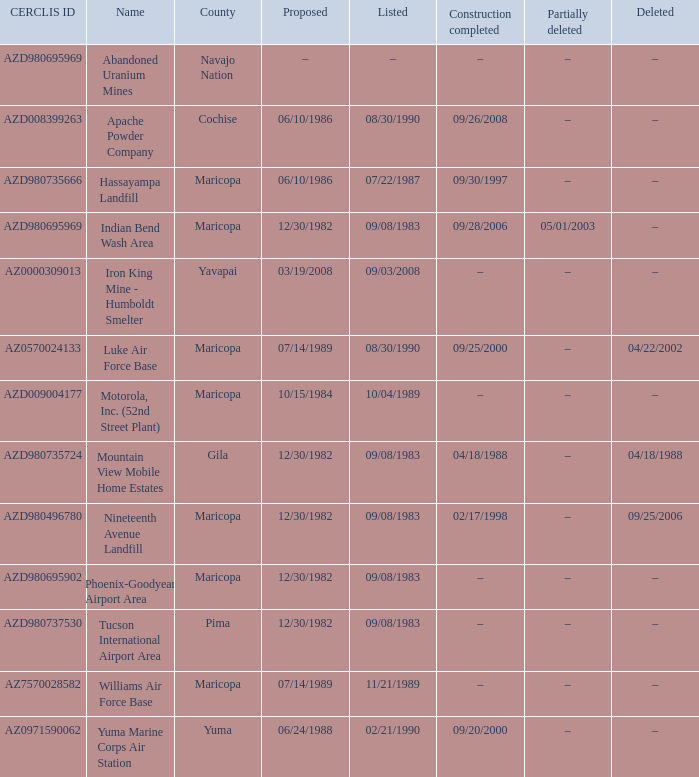Can you provide the cerclis id of the site that was suggested on 12/30/1982 and underwent partial deletion on 05/01/2003? AZD980695969. 